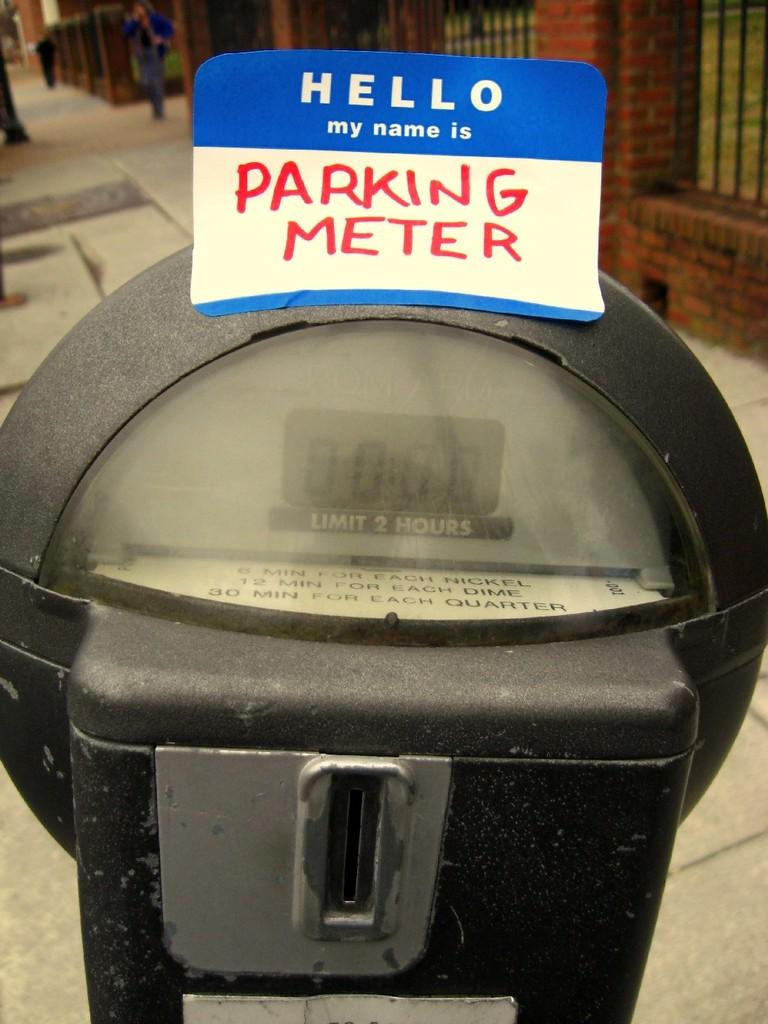What object is the main focus of the image? There is a parking meter in the image. What is the color of the parking meter? The parking meter is black and ash in color. What is attached to the parking meter? There is a board on the parking meter. What can be seen in the background of the image? There is fencing, a brick wall, and people visible in the background. What type of cushion is being used to cover the parking meter in the image? There is no cushion present in the image; the parking meter is not covered. What type of quilt is being used to decorate the brick wall in the image? There is no quilt present in the image; the brick wall is not decorated with a quilt. 